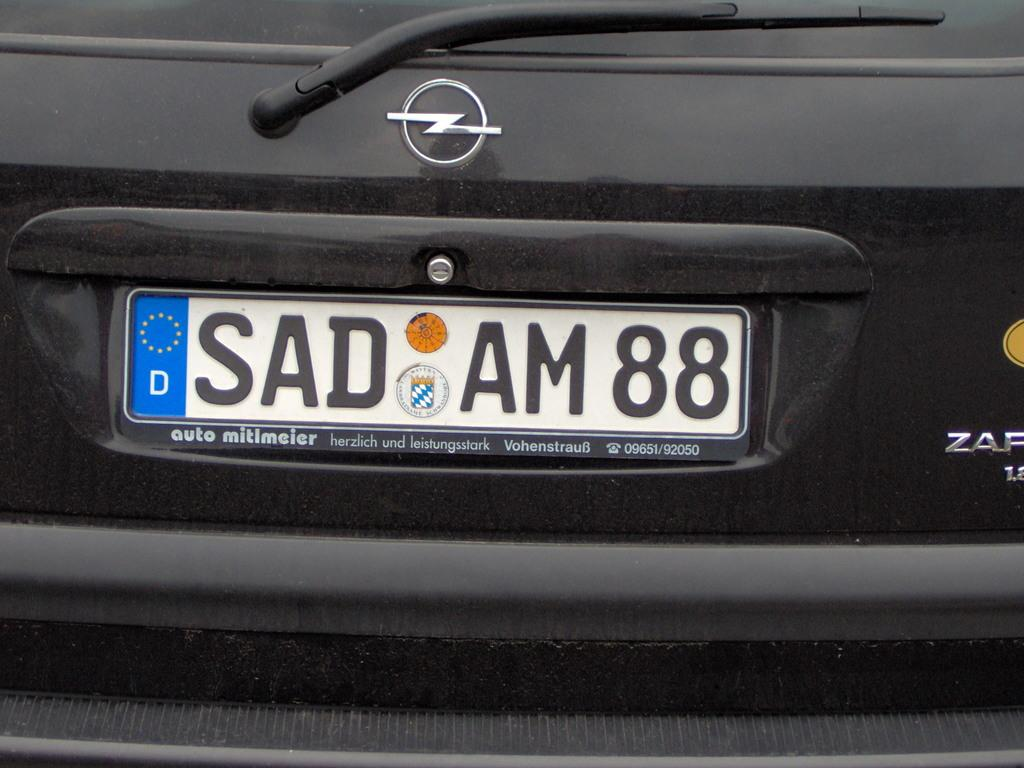Provide a one-sentence caption for the provided image. A german license plate (SAD AM88) on a black vehicle. 